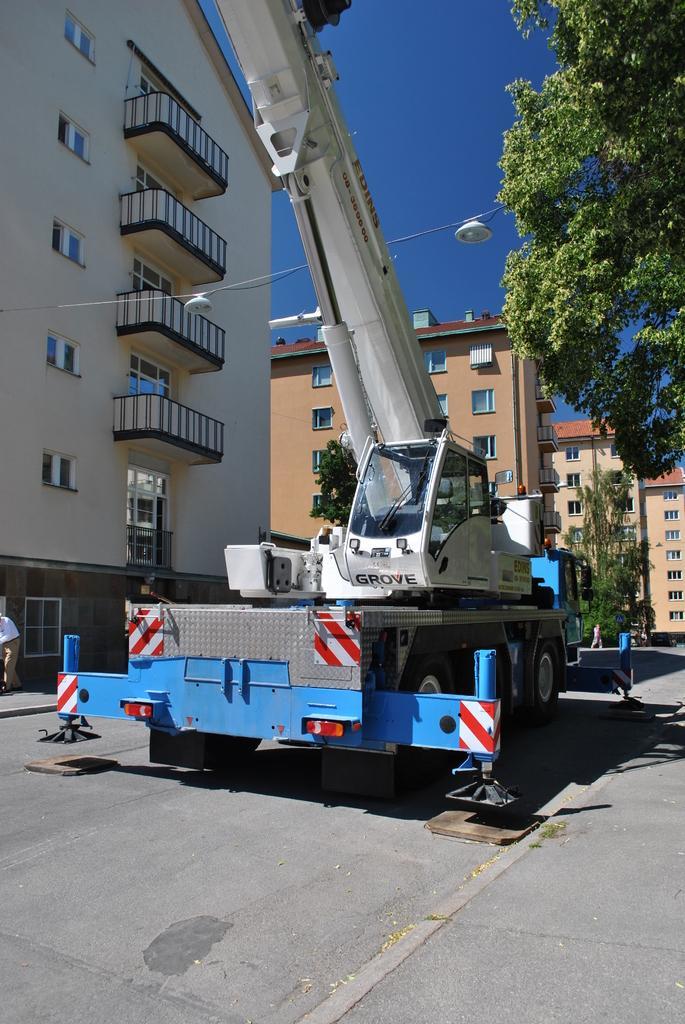Could you give a brief overview of what you see in this image? In this image I can see few buildings and glass windows. I can see a vehicle,trees,light-pole and few people on the road. The sky is in blue color. 